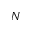<formula> <loc_0><loc_0><loc_500><loc_500>N</formula> 